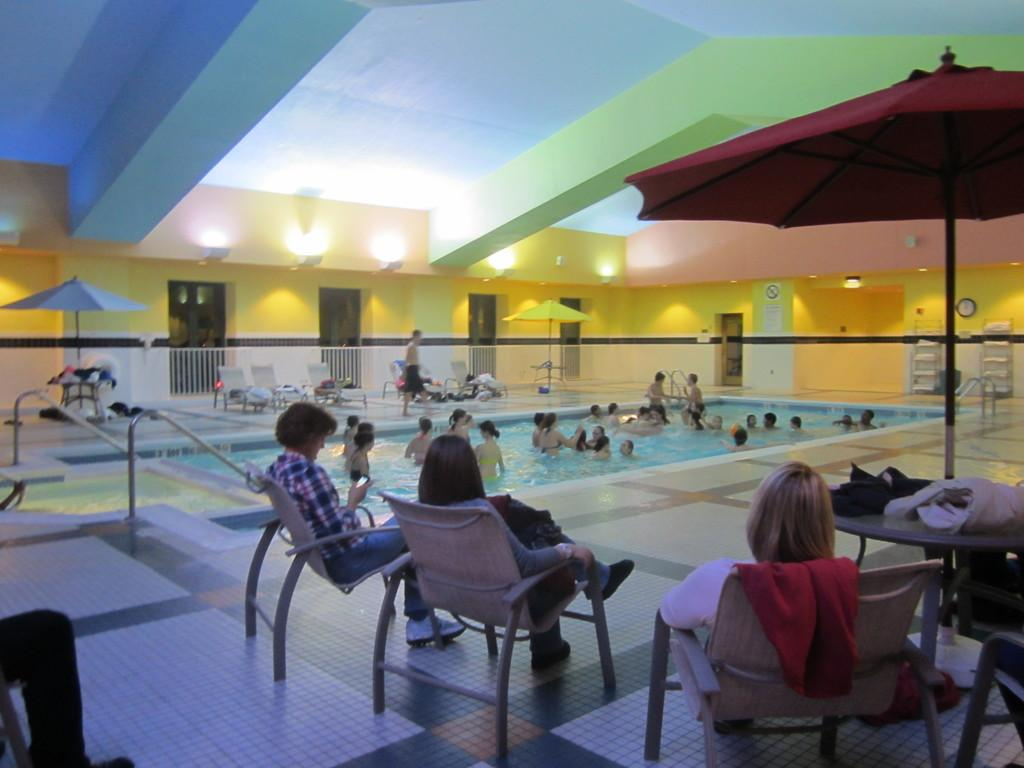What are the people in the image doing? There are people in the pool and people sitting in chairs. What is providing shade for the people sitting in chairs? The chairs are under an umbrella. What is the man beside the pool doing? There is a man walking beside the pool. What type of dust can be seen settling on the drum in the image? There is no drum present in the image, so it is not possible to determine if dust is settling on it. 